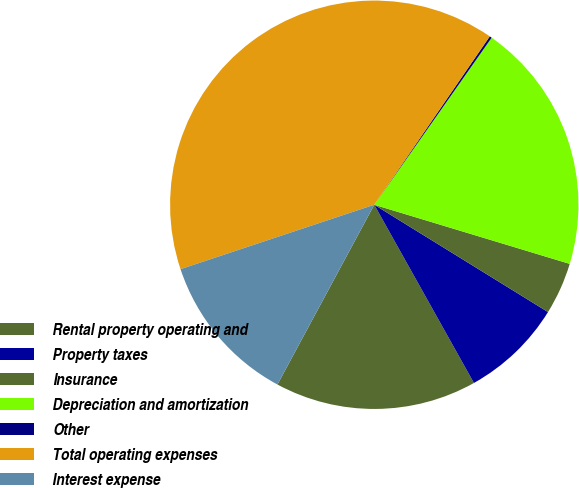<chart> <loc_0><loc_0><loc_500><loc_500><pie_chart><fcel>Rental property operating and<fcel>Property taxes<fcel>Insurance<fcel>Depreciation and amortization<fcel>Other<fcel>Total operating expenses<fcel>Interest expense<nl><fcel>15.98%<fcel>8.08%<fcel>4.13%<fcel>19.93%<fcel>0.18%<fcel>39.68%<fcel>12.03%<nl></chart> 